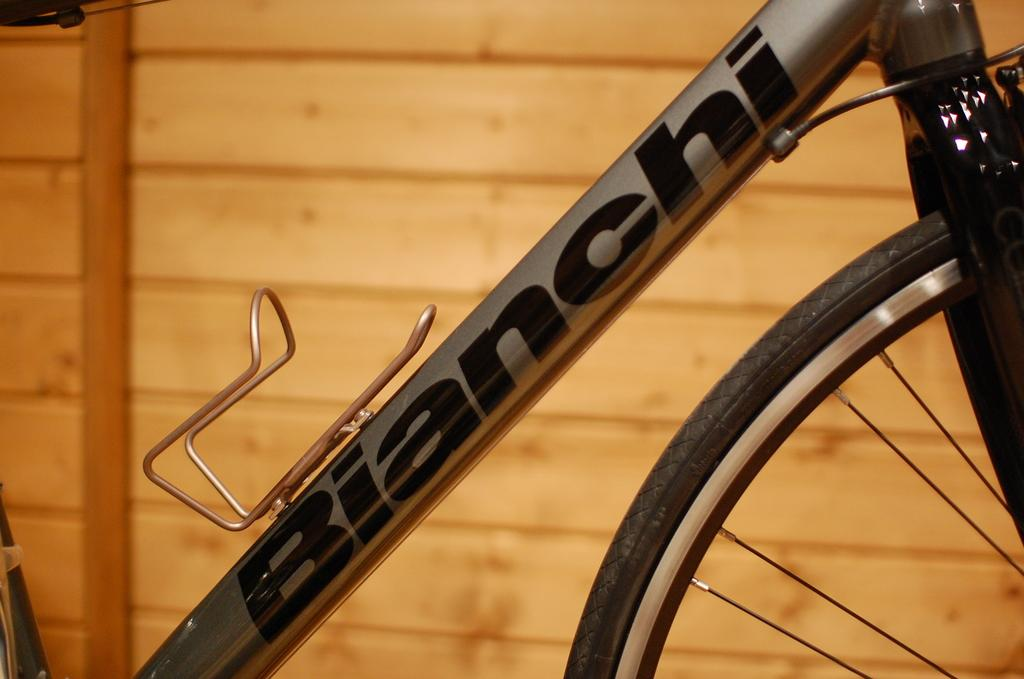What object related to transportation can be seen in the image? There is a part of a bicycle in the image. What specific part of the bicycle is visible? The bicycle has a tire. What type of material can be seen in the background of the image? There is a wooden wall in the background of the image. What type of stamp can be seen on the bicycle tire in the image? There is no stamp present on the bicycle tire in the image. What kind of music is being played in the background of the image? There is no music present in the image; it only features a part of a bicycle and a wooden wall in the background. 